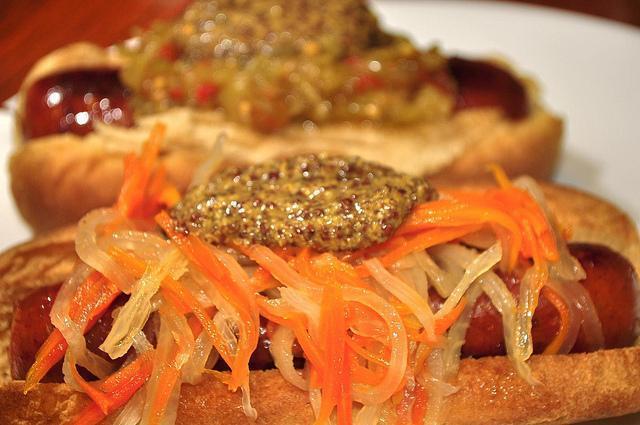How many hot dogs can be seen?
Give a very brief answer. 2. How many people are driving a motorcycle in this image?
Give a very brief answer. 0. 